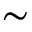Convert formula to latex. <formula><loc_0><loc_0><loc_500><loc_500>\sim</formula> 